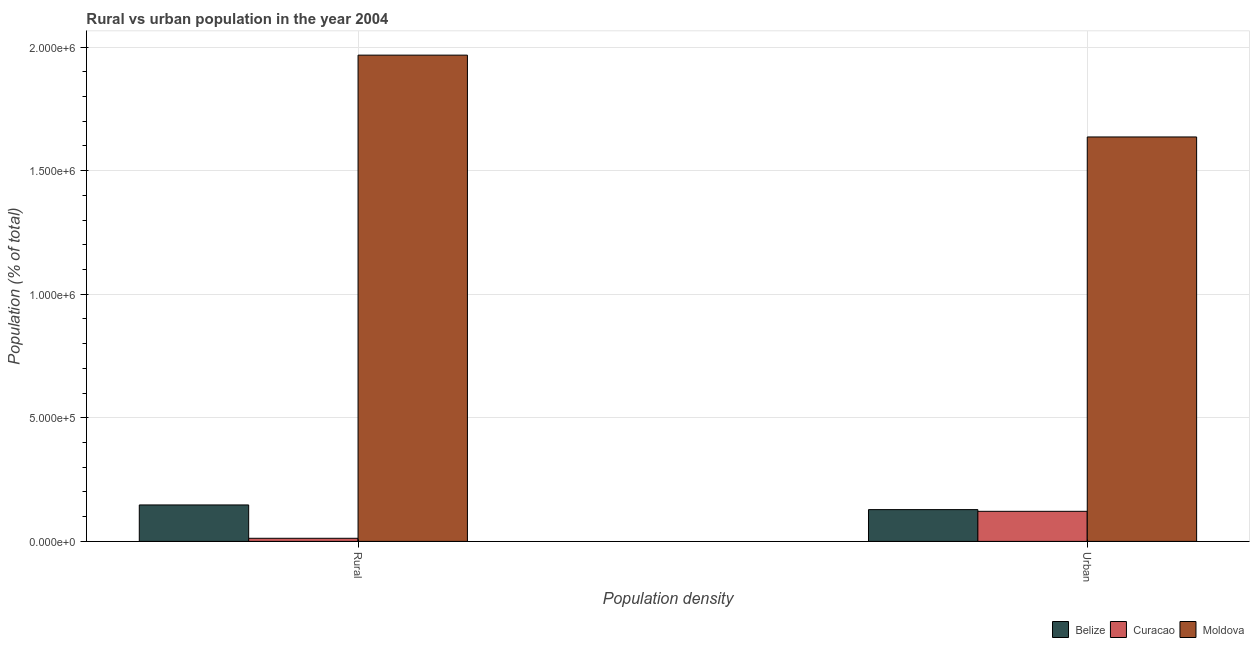How many different coloured bars are there?
Ensure brevity in your answer.  3. Are the number of bars per tick equal to the number of legend labels?
Give a very brief answer. Yes. Are the number of bars on each tick of the X-axis equal?
Make the answer very short. Yes. How many bars are there on the 1st tick from the left?
Ensure brevity in your answer.  3. How many bars are there on the 2nd tick from the right?
Provide a succinct answer. 3. What is the label of the 2nd group of bars from the left?
Give a very brief answer. Urban. What is the urban population density in Curacao?
Your answer should be very brief. 1.22e+05. Across all countries, what is the maximum urban population density?
Your answer should be very brief. 1.64e+06. Across all countries, what is the minimum urban population density?
Provide a short and direct response. 1.22e+05. In which country was the urban population density maximum?
Your answer should be very brief. Moldova. In which country was the rural population density minimum?
Offer a terse response. Curacao. What is the total rural population density in the graph?
Keep it short and to the point. 2.13e+06. What is the difference between the rural population density in Belize and that in Curacao?
Your answer should be compact. 1.35e+05. What is the difference between the urban population density in Curacao and the rural population density in Belize?
Provide a succinct answer. -2.58e+04. What is the average rural population density per country?
Offer a terse response. 7.09e+05. What is the difference between the rural population density and urban population density in Moldova?
Offer a terse response. 3.31e+05. What is the ratio of the rural population density in Belize to that in Curacao?
Your answer should be compact. 11.76. Is the urban population density in Curacao less than that in Moldova?
Offer a very short reply. Yes. What does the 1st bar from the left in Rural represents?
Provide a succinct answer. Belize. What does the 1st bar from the right in Rural represents?
Provide a short and direct response. Moldova. How many bars are there?
Make the answer very short. 6. Are all the bars in the graph horizontal?
Your answer should be very brief. No. How many countries are there in the graph?
Ensure brevity in your answer.  3. Does the graph contain any zero values?
Give a very brief answer. No. How many legend labels are there?
Offer a very short reply. 3. What is the title of the graph?
Give a very brief answer. Rural vs urban population in the year 2004. What is the label or title of the X-axis?
Offer a very short reply. Population density. What is the label or title of the Y-axis?
Your answer should be very brief. Population (% of total). What is the Population (% of total) of Belize in Rural?
Offer a terse response. 1.47e+05. What is the Population (% of total) of Curacao in Rural?
Keep it short and to the point. 1.25e+04. What is the Population (% of total) in Moldova in Rural?
Give a very brief answer. 1.97e+06. What is the Population (% of total) of Belize in Urban?
Your answer should be compact. 1.29e+05. What is the Population (% of total) of Curacao in Urban?
Ensure brevity in your answer.  1.22e+05. What is the Population (% of total) in Moldova in Urban?
Provide a succinct answer. 1.64e+06. Across all Population density, what is the maximum Population (% of total) in Belize?
Give a very brief answer. 1.47e+05. Across all Population density, what is the maximum Population (% of total) in Curacao?
Offer a very short reply. 1.22e+05. Across all Population density, what is the maximum Population (% of total) in Moldova?
Keep it short and to the point. 1.97e+06. Across all Population density, what is the minimum Population (% of total) of Belize?
Offer a very short reply. 1.29e+05. Across all Population density, what is the minimum Population (% of total) of Curacao?
Your answer should be compact. 1.25e+04. Across all Population density, what is the minimum Population (% of total) in Moldova?
Offer a very short reply. 1.64e+06. What is the total Population (% of total) of Belize in the graph?
Offer a terse response. 2.76e+05. What is the total Population (% of total) of Curacao in the graph?
Provide a short and direct response. 1.34e+05. What is the total Population (% of total) of Moldova in the graph?
Your answer should be compact. 3.60e+06. What is the difference between the Population (% of total) of Belize in Rural and that in Urban?
Offer a terse response. 1.89e+04. What is the difference between the Population (% of total) in Curacao in Rural and that in Urban?
Your answer should be compact. -1.09e+05. What is the difference between the Population (% of total) in Moldova in Rural and that in Urban?
Offer a terse response. 3.31e+05. What is the difference between the Population (% of total) in Belize in Rural and the Population (% of total) in Curacao in Urban?
Keep it short and to the point. 2.58e+04. What is the difference between the Population (% of total) of Belize in Rural and the Population (% of total) of Moldova in Urban?
Give a very brief answer. -1.49e+06. What is the difference between the Population (% of total) of Curacao in Rural and the Population (% of total) of Moldova in Urban?
Ensure brevity in your answer.  -1.62e+06. What is the average Population (% of total) in Belize per Population density?
Offer a very short reply. 1.38e+05. What is the average Population (% of total) of Curacao per Population density?
Keep it short and to the point. 6.71e+04. What is the average Population (% of total) of Moldova per Population density?
Offer a very short reply. 1.80e+06. What is the difference between the Population (% of total) in Belize and Population (% of total) in Curacao in Rural?
Ensure brevity in your answer.  1.35e+05. What is the difference between the Population (% of total) in Belize and Population (% of total) in Moldova in Rural?
Provide a short and direct response. -1.82e+06. What is the difference between the Population (% of total) in Curacao and Population (% of total) in Moldova in Rural?
Make the answer very short. -1.95e+06. What is the difference between the Population (% of total) in Belize and Population (% of total) in Curacao in Urban?
Keep it short and to the point. 6948. What is the difference between the Population (% of total) of Belize and Population (% of total) of Moldova in Urban?
Give a very brief answer. -1.51e+06. What is the difference between the Population (% of total) in Curacao and Population (% of total) in Moldova in Urban?
Provide a short and direct response. -1.51e+06. What is the ratio of the Population (% of total) of Belize in Rural to that in Urban?
Make the answer very short. 1.15. What is the ratio of the Population (% of total) in Curacao in Rural to that in Urban?
Your response must be concise. 0.1. What is the ratio of the Population (% of total) in Moldova in Rural to that in Urban?
Make the answer very short. 1.2. What is the difference between the highest and the second highest Population (% of total) in Belize?
Your answer should be compact. 1.89e+04. What is the difference between the highest and the second highest Population (% of total) of Curacao?
Provide a short and direct response. 1.09e+05. What is the difference between the highest and the second highest Population (% of total) in Moldova?
Ensure brevity in your answer.  3.31e+05. What is the difference between the highest and the lowest Population (% of total) in Belize?
Offer a terse response. 1.89e+04. What is the difference between the highest and the lowest Population (% of total) in Curacao?
Give a very brief answer. 1.09e+05. What is the difference between the highest and the lowest Population (% of total) in Moldova?
Your answer should be very brief. 3.31e+05. 